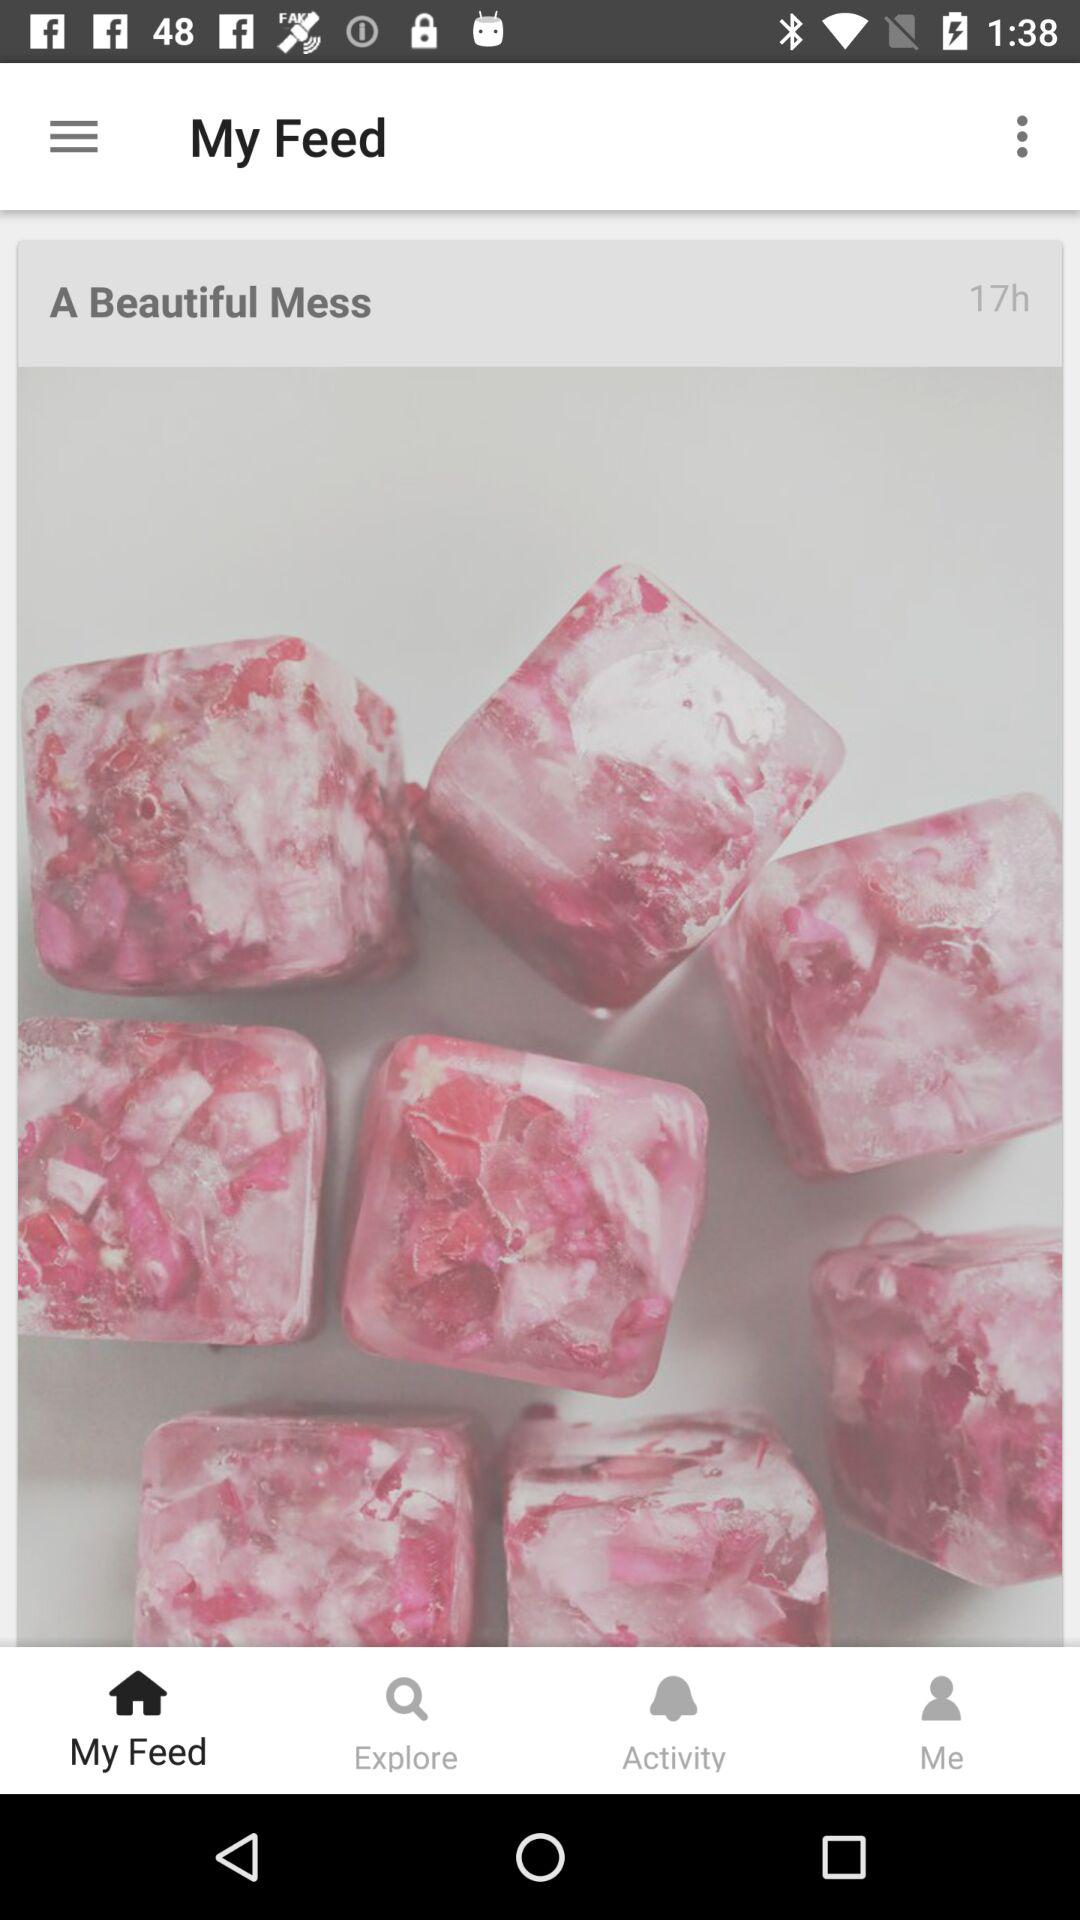How many hours ago was "A Beautiful Mess" posted in "My Feed"? "A Beautiful Mess" was posted 17 hours ago. 